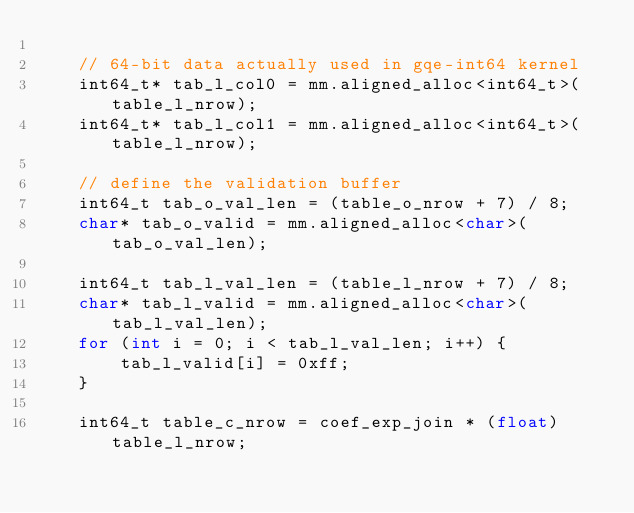Convert code to text. <code><loc_0><loc_0><loc_500><loc_500><_C++_>
    // 64-bit data actually used in gqe-int64 kernel
    int64_t* tab_l_col0 = mm.aligned_alloc<int64_t>(table_l_nrow);
    int64_t* tab_l_col1 = mm.aligned_alloc<int64_t>(table_l_nrow);

    // define the validation buffer
    int64_t tab_o_val_len = (table_o_nrow + 7) / 8;
    char* tab_o_valid = mm.aligned_alloc<char>(tab_o_val_len);

    int64_t tab_l_val_len = (table_l_nrow + 7) / 8;
    char* tab_l_valid = mm.aligned_alloc<char>(tab_l_val_len);
    for (int i = 0; i < tab_l_val_len; i++) {
        tab_l_valid[i] = 0xff;
    }

    int64_t table_c_nrow = coef_exp_join * (float)table_l_nrow;</code> 